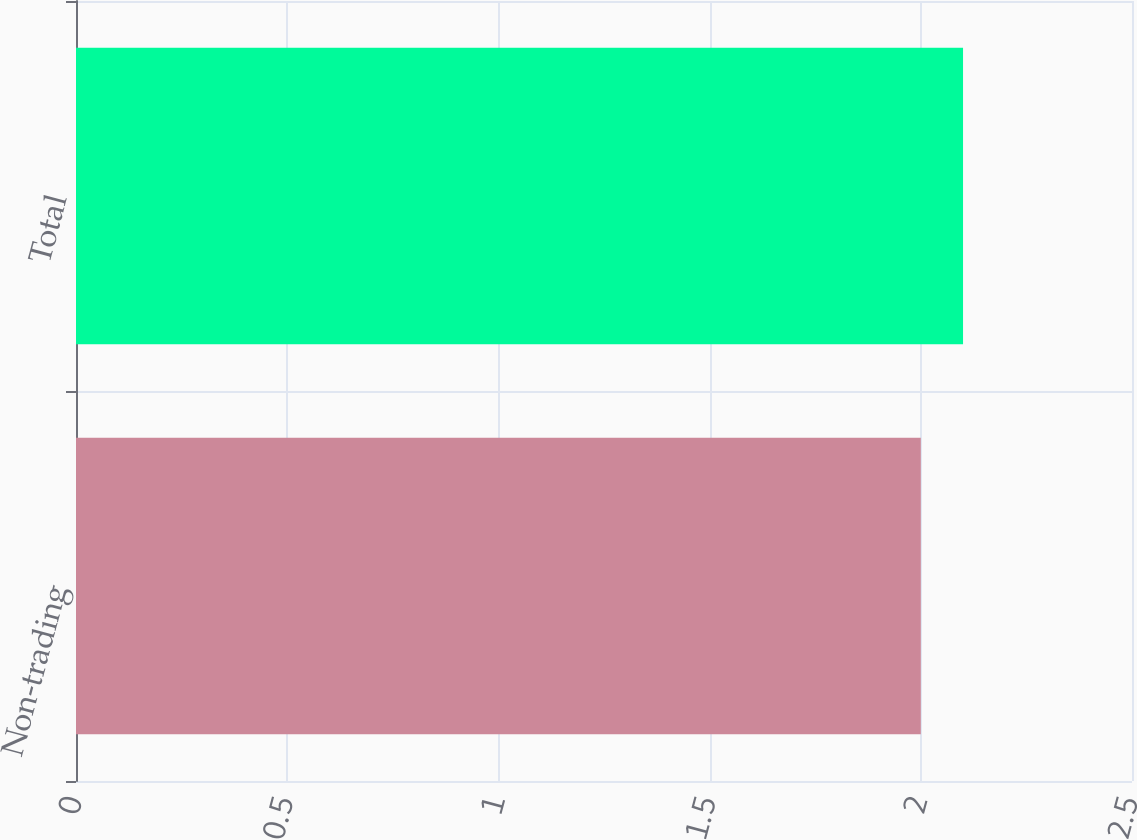Convert chart to OTSL. <chart><loc_0><loc_0><loc_500><loc_500><bar_chart><fcel>Non-trading<fcel>Total<nl><fcel>2<fcel>2.1<nl></chart> 